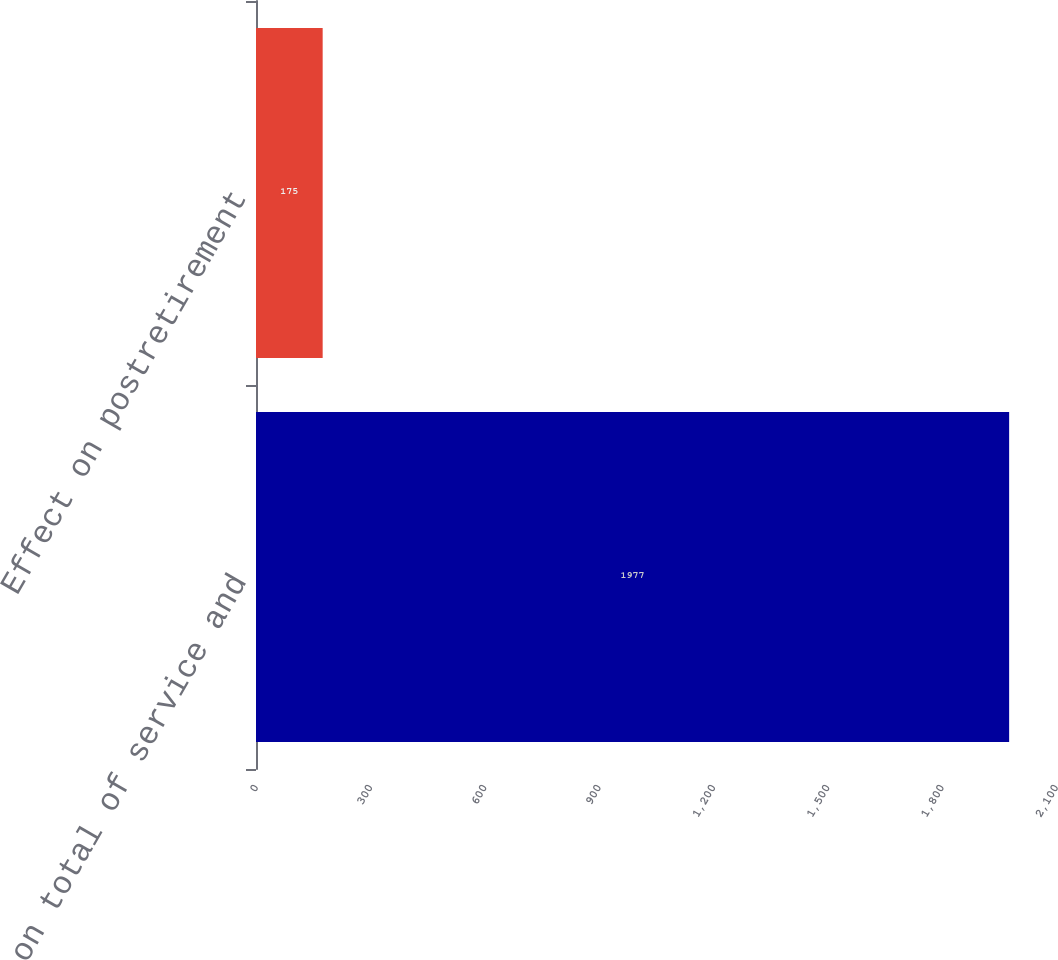<chart> <loc_0><loc_0><loc_500><loc_500><bar_chart><fcel>Effect on total of service and<fcel>Effect on postretirement<nl><fcel>1977<fcel>175<nl></chart> 